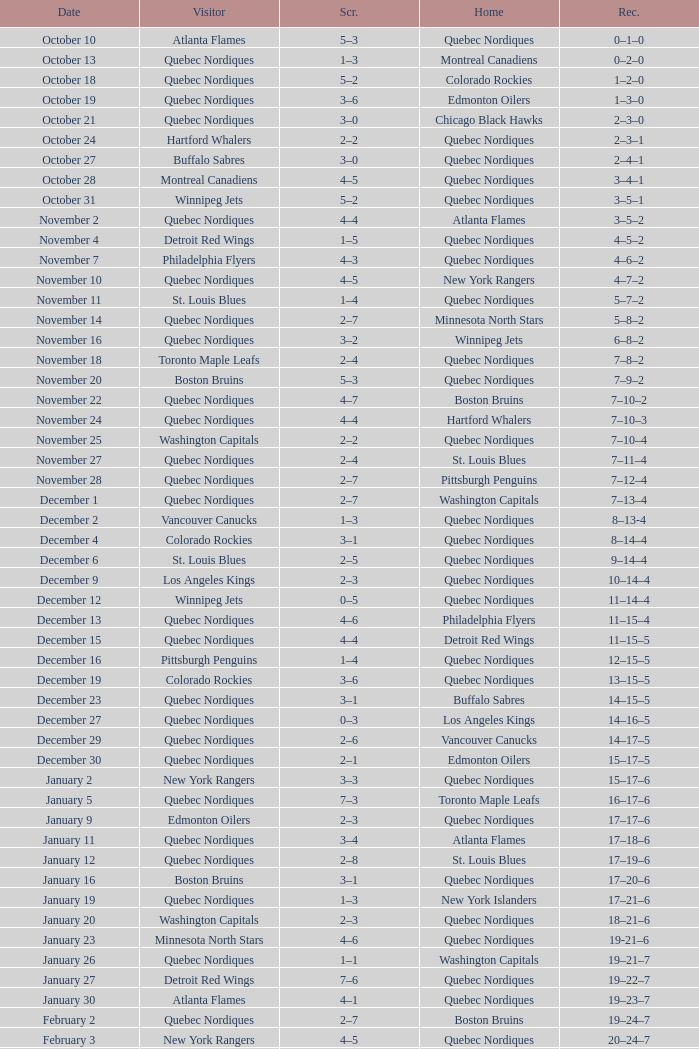Which Home has a Record of 16–17–6? Toronto Maple Leafs. 